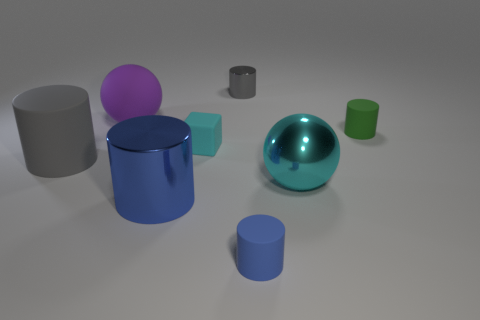Subtract all green cylinders. How many cylinders are left? 4 Subtract all yellow cylinders. Subtract all gray blocks. How many cylinders are left? 5 Add 1 small cyan rubber blocks. How many objects exist? 9 Subtract all spheres. How many objects are left? 6 Subtract 0 blue balls. How many objects are left? 8 Subtract all small green things. Subtract all small blue objects. How many objects are left? 6 Add 5 tiny gray shiny cylinders. How many tiny gray shiny cylinders are left? 6 Add 3 small brown objects. How many small brown objects exist? 3 